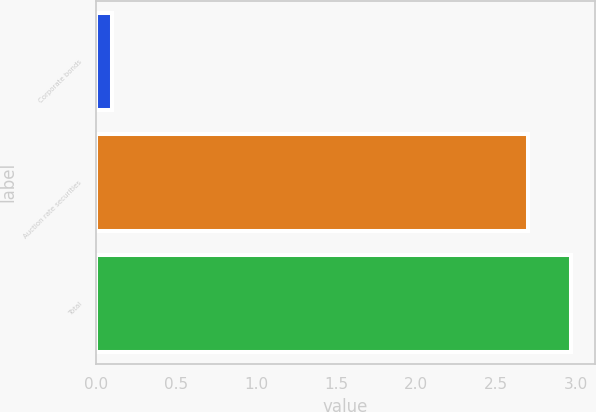<chart> <loc_0><loc_0><loc_500><loc_500><bar_chart><fcel>Corporate bonds<fcel>Auction rate securities<fcel>Total<nl><fcel>0.1<fcel>2.7<fcel>2.97<nl></chart> 